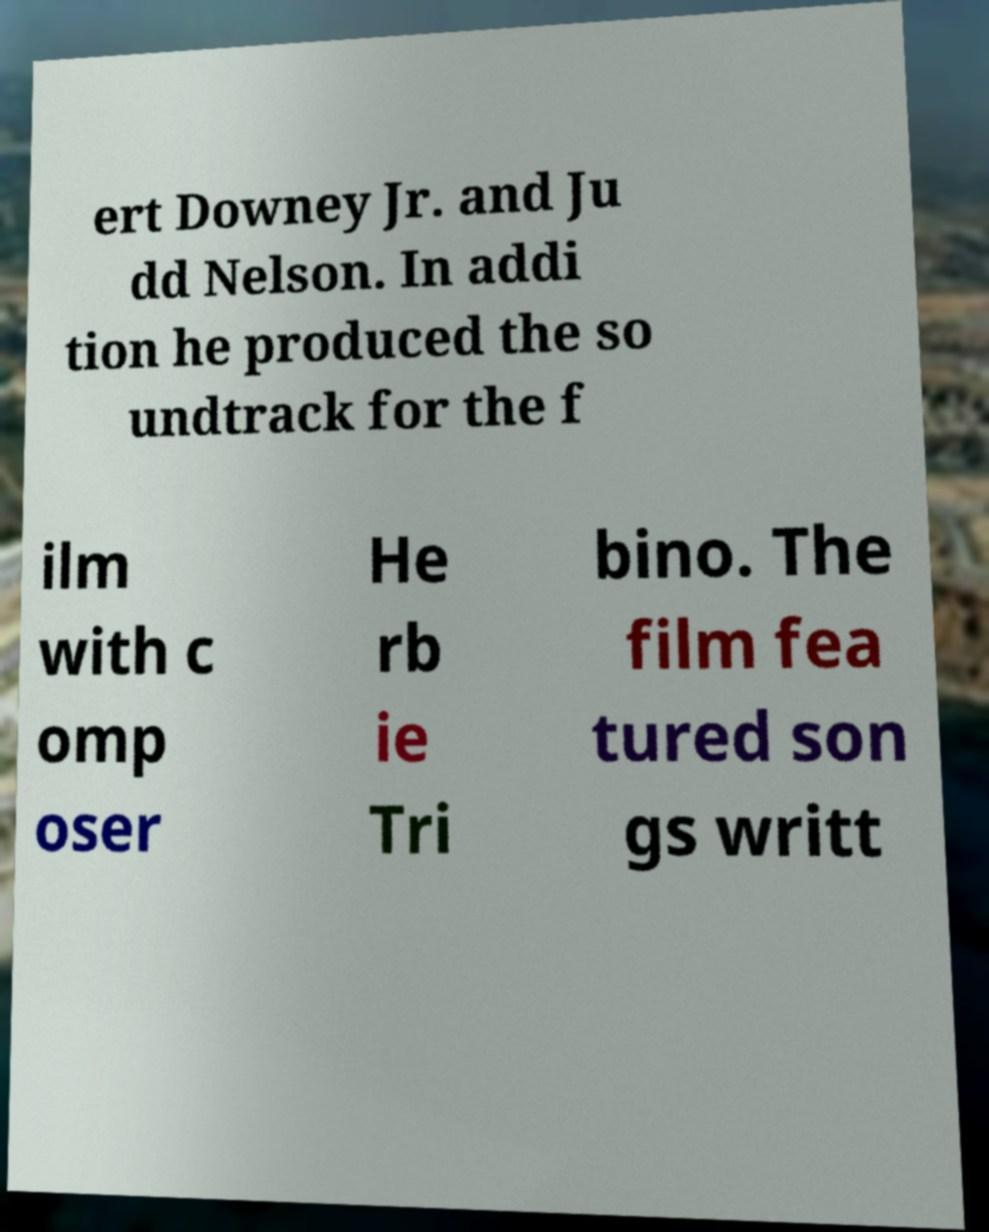Can you read and provide the text displayed in the image?This photo seems to have some interesting text. Can you extract and type it out for me? ert Downey Jr. and Ju dd Nelson. In addi tion he produced the so undtrack for the f ilm with c omp oser He rb ie Tri bino. The film fea tured son gs writt 